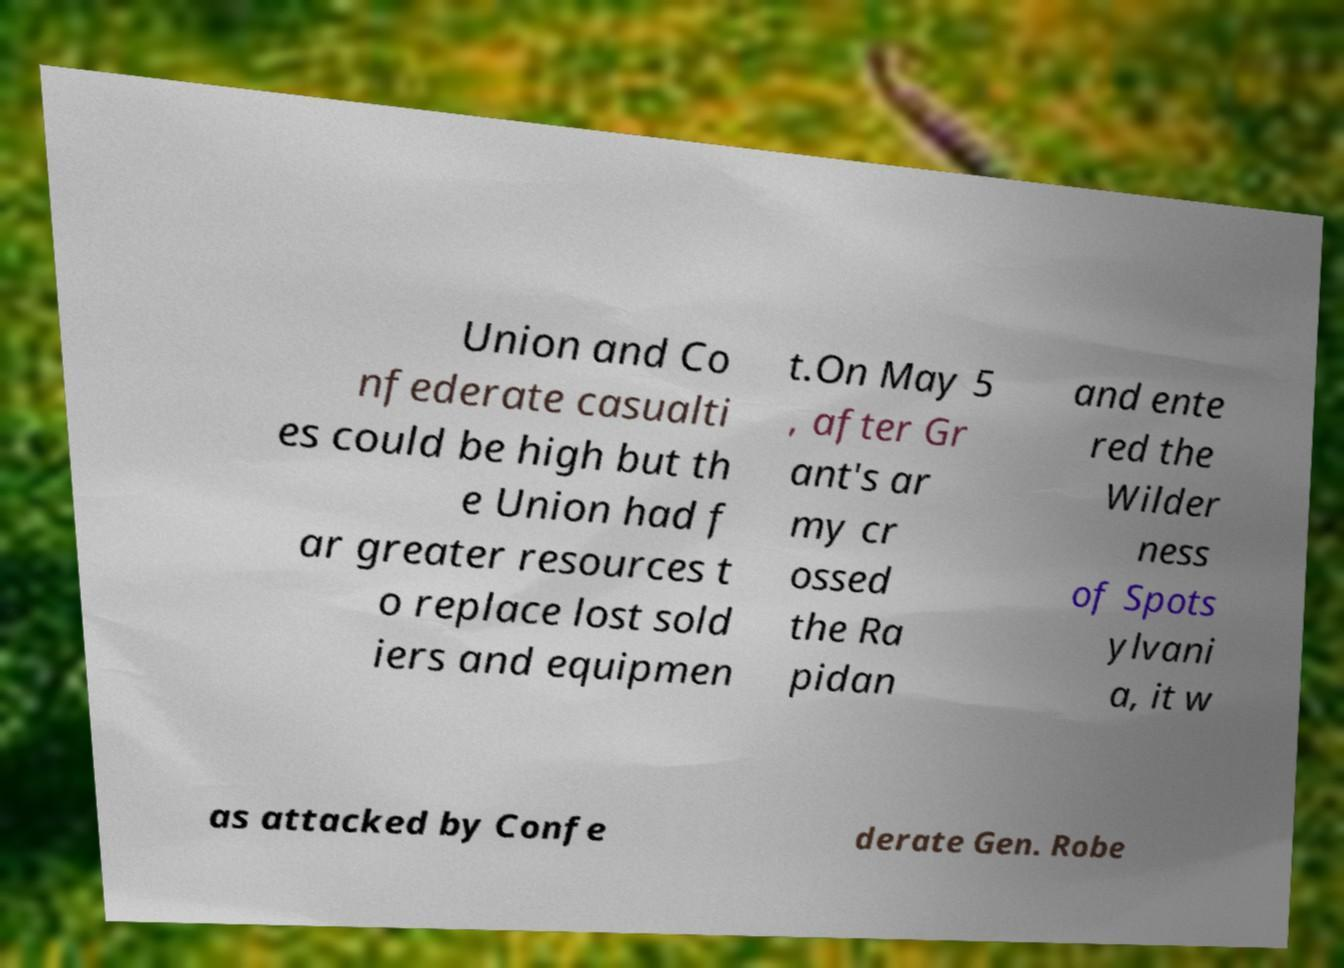Could you assist in decoding the text presented in this image and type it out clearly? Union and Co nfederate casualti es could be high but th e Union had f ar greater resources t o replace lost sold iers and equipmen t.On May 5 , after Gr ant's ar my cr ossed the Ra pidan and ente red the Wilder ness of Spots ylvani a, it w as attacked by Confe derate Gen. Robe 